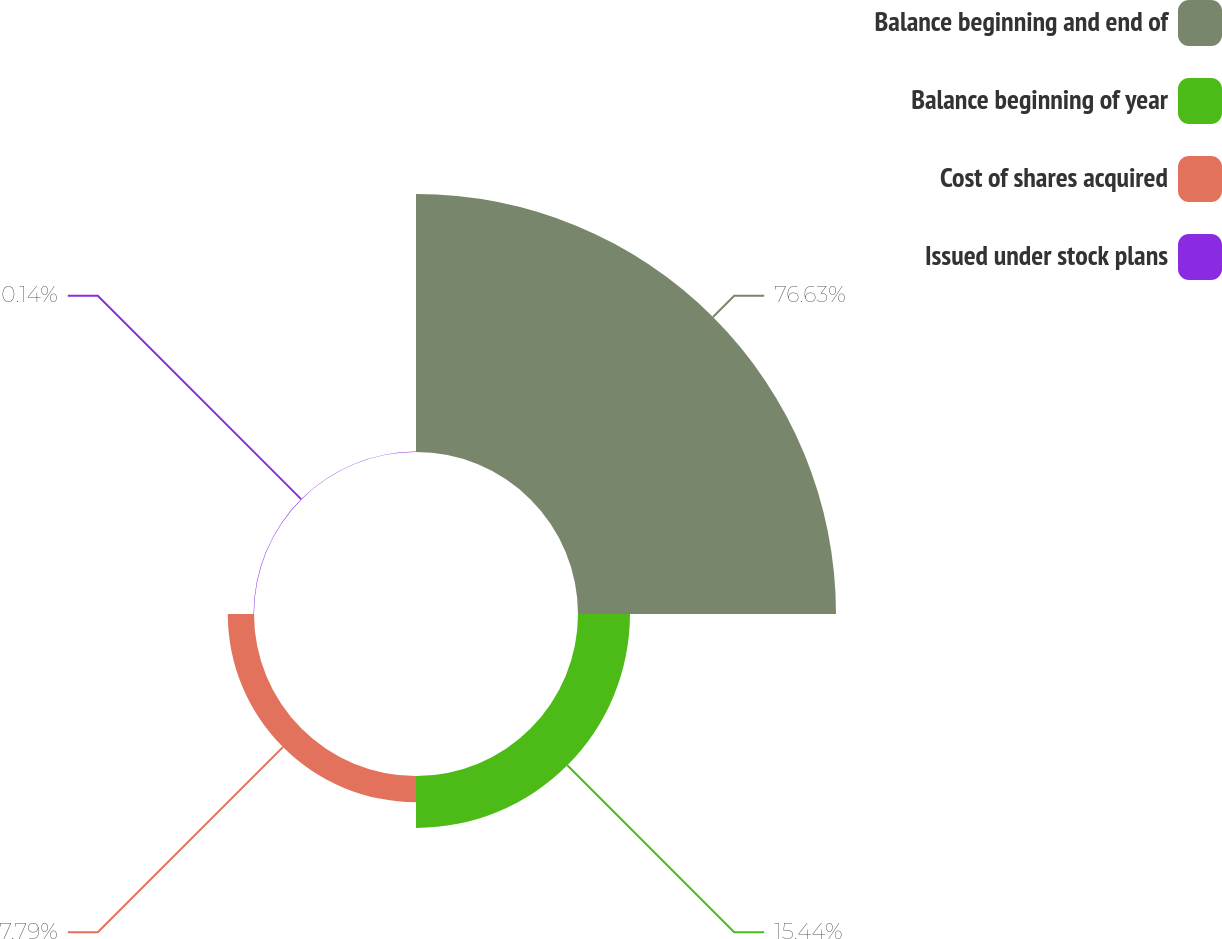Convert chart. <chart><loc_0><loc_0><loc_500><loc_500><pie_chart><fcel>Balance beginning and end of<fcel>Balance beginning of year<fcel>Cost of shares acquired<fcel>Issued under stock plans<nl><fcel>76.64%<fcel>15.44%<fcel>7.79%<fcel>0.14%<nl></chart> 